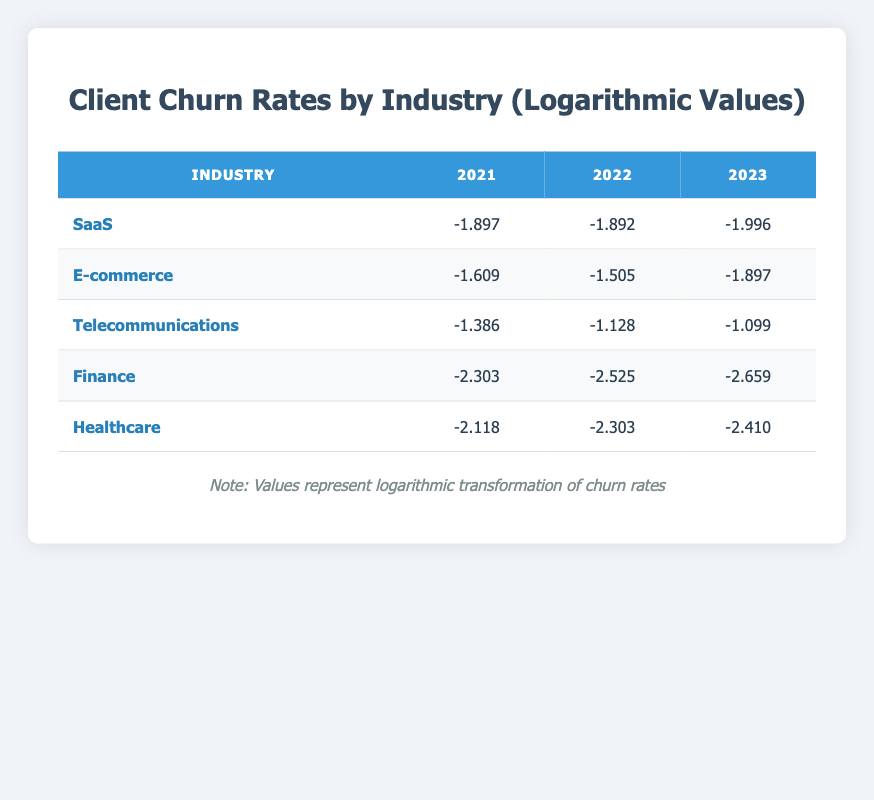What are the churn rates for the SaaS industry in 2022? The table shows the churn rate for the SaaS industry in 2022 as 0.12.
Answer: 0.12 Which industry had the highest churn rate in 2021? The table indicates that the Telecommunications industry had the highest churn rate in 2021 at 0.25.
Answer: Telecommunications What is the logarithmic value of the churn rate for Finance in 2023? According to the table, the logarithmic value of the churn rate for Finance in 2023 is -2.659.
Answer: -2.659 What is the difference in churn rates between E-commerce in 2021 and 2023? The churn rate for E-commerce was 0.20 in 2021 and decreased to 0.15 in 2023. The difference is 0.20 - 0.15 = 0.05.
Answer: 0.05 Is the churn rate for Healthcare in 2022 lower than 0.10? The table shows that the churn rate for Healthcare in 2022 is 0.10, which is not lower than 0.10. Thus, the answer is no.
Answer: No What was the average churn rate for SaaS over the three years? To find the average churn rate for SaaS, sum the churn rates (0.15 + 0.12 + 0.10 = 0.37) and divide by 3. So, the average is 0.37 / 3 = 0.1233.
Answer: 0.1233 Which industry showed the most significant decrease in churn rate from 2021 to 2023? The Finance industry's churn rate decreased from 0.10 in 2021 to 0.07 in 2023, a decrease of 0.03. In contrast, the E-commerce industry decreased by 0.05 (0.20 to 0.15) and SaaS decreased by 0.05 (0.15 to 0.10). Therefore, Finance shows the most significant decrease.
Answer: Finance In which year did the Telecommunications industry have the lowest logarithmic value? The table shows that the Telecommunications industry's lowest logarithmic value is -1.099, which occurred in 2023.
Answer: 2023 What is the trend for churn rates in the Finance industry over the three years? Looking at the table, the churn rates for Finance have decreased each year: from 0.10 in 2021 to 0.08 in 2022, and then to 0.07 in 2023, indicating a consistent downward trend.
Answer: Downward trend 